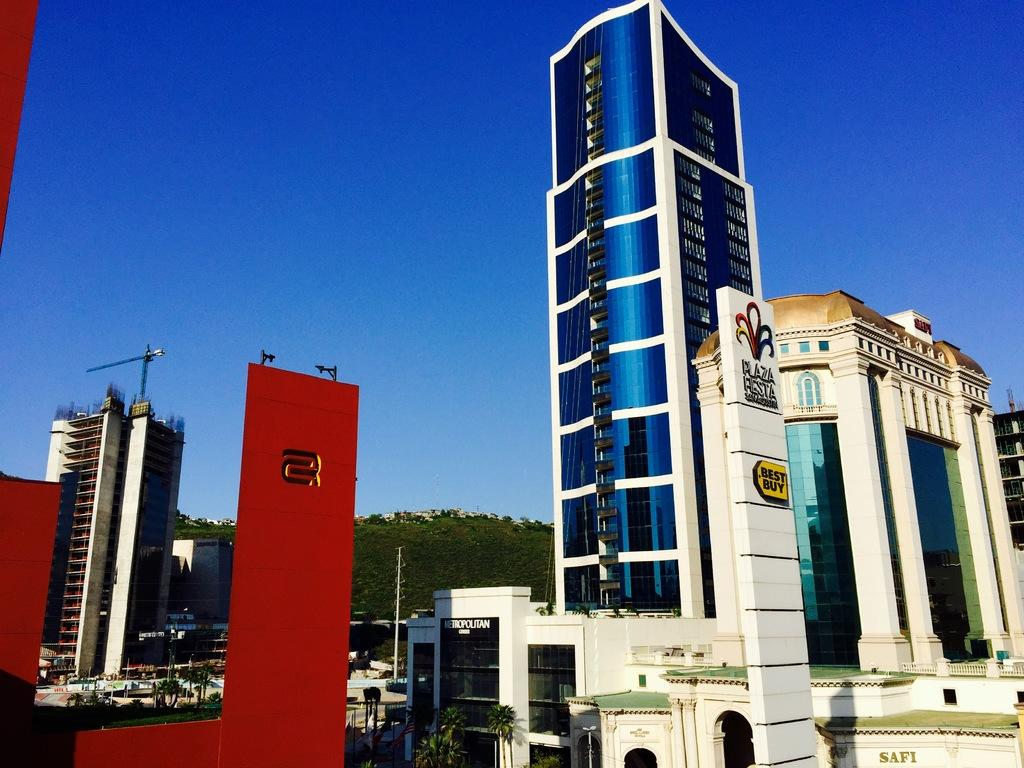What type of view is shown in the image? The image is an outside view. What can be seen at the bottom of the image? There are many buildings and trees at the bottom of the image. What is located on the left side of the image? There is a crane on the left side of the image. What is visible at the top of the image? The sky is visible at the top of the image. What is the color of the sky in the image? The color of the sky is blue. What type of seed is being used to lead the destruction of the buildings in the image? There is no seed, lead, or destruction present in the image. The image shows buildings, trees, a crane, and a blue sky. 